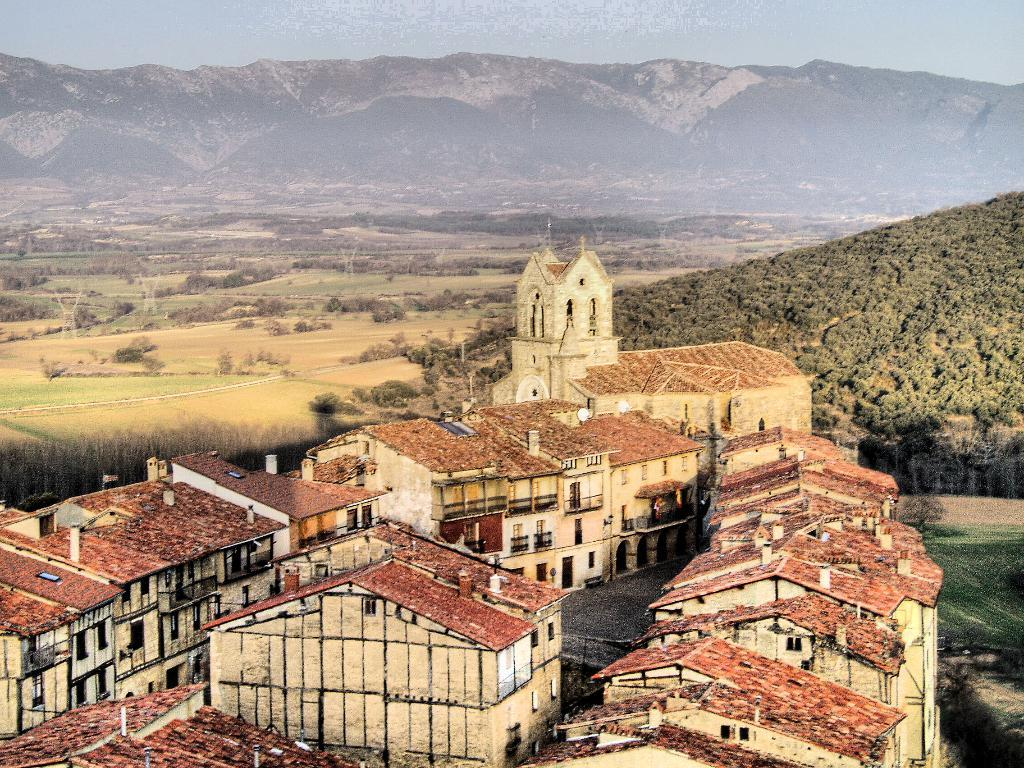What type of structures can be seen in the image? There are buildings with rooftops in the image. Can you identify any specific type of building in the image? Yes, there is a church in the image. What can be seen in the background of the image? There are mountains, hills, trees, and grass in the background of the image. Where is the quicksand located in the image? There is no quicksand present in the image. What type of currency can be seen in the image? There is no money visible in the image. 